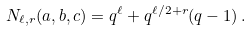Convert formula to latex. <formula><loc_0><loc_0><loc_500><loc_500>N _ { \ell , r } ( a , b , c ) = q ^ { \ell } + q ^ { \ell / 2 + r } ( q - 1 ) \, .</formula> 